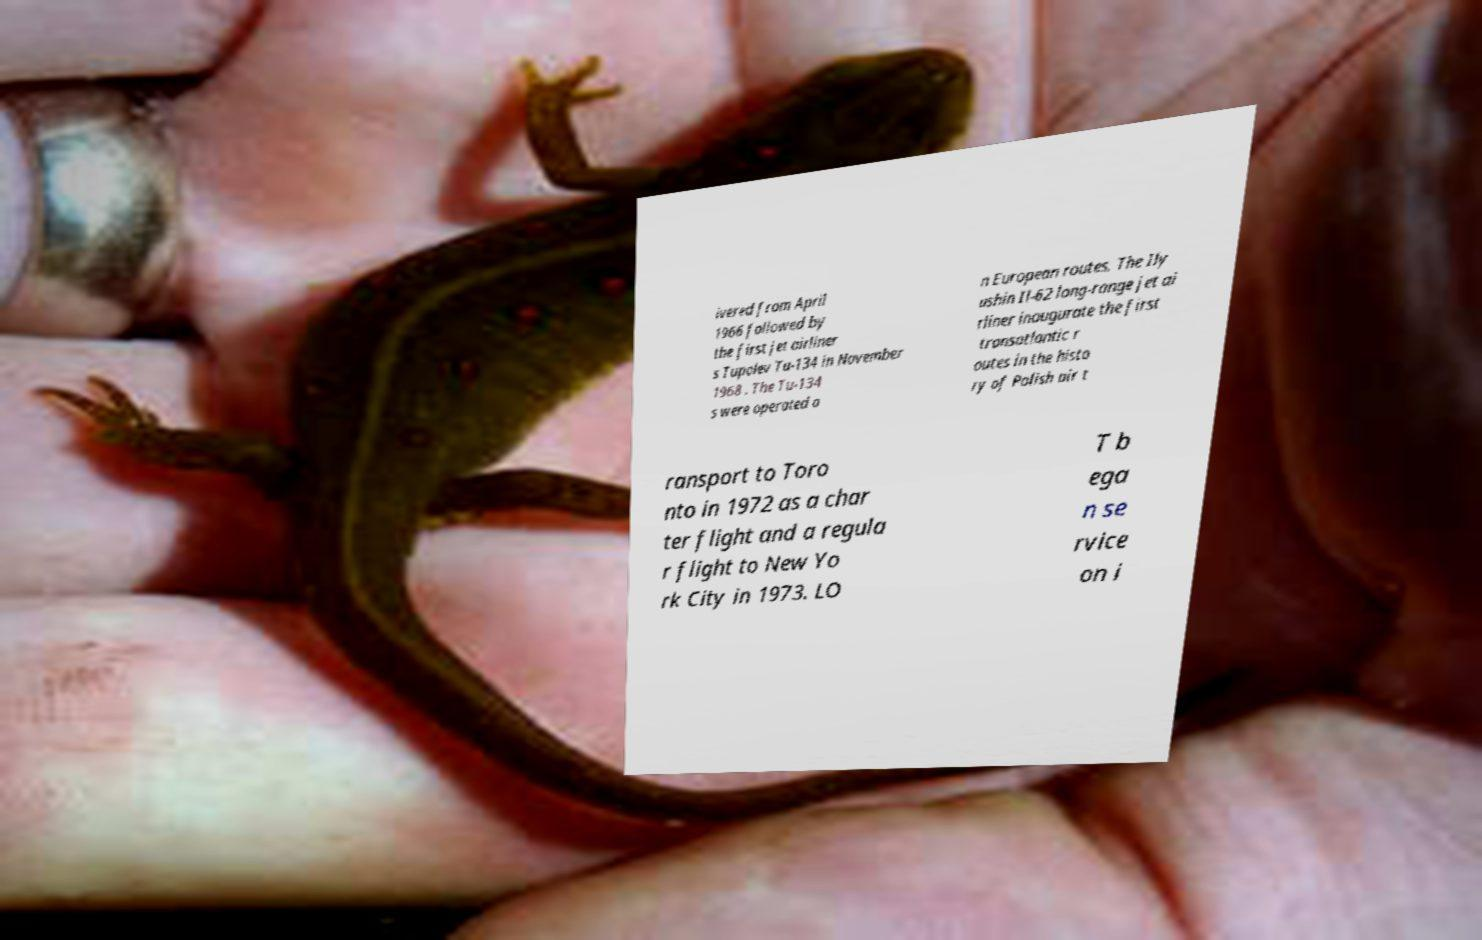There's text embedded in this image that I need extracted. Can you transcribe it verbatim? ivered from April 1966 followed by the first jet airliner s Tupolev Tu-134 in November 1968 . The Tu-134 s were operated o n European routes. The Ily ushin Il-62 long-range jet ai rliner inaugurate the first transatlantic r outes in the histo ry of Polish air t ransport to Toro nto in 1972 as a char ter flight and a regula r flight to New Yo rk City in 1973. LO T b ega n se rvice on i 